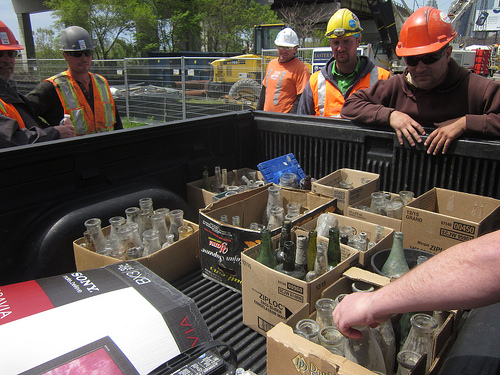<image>
Is the helmet on the man? No. The helmet is not positioned on the man. They may be near each other, but the helmet is not supported by or resting on top of the man. 